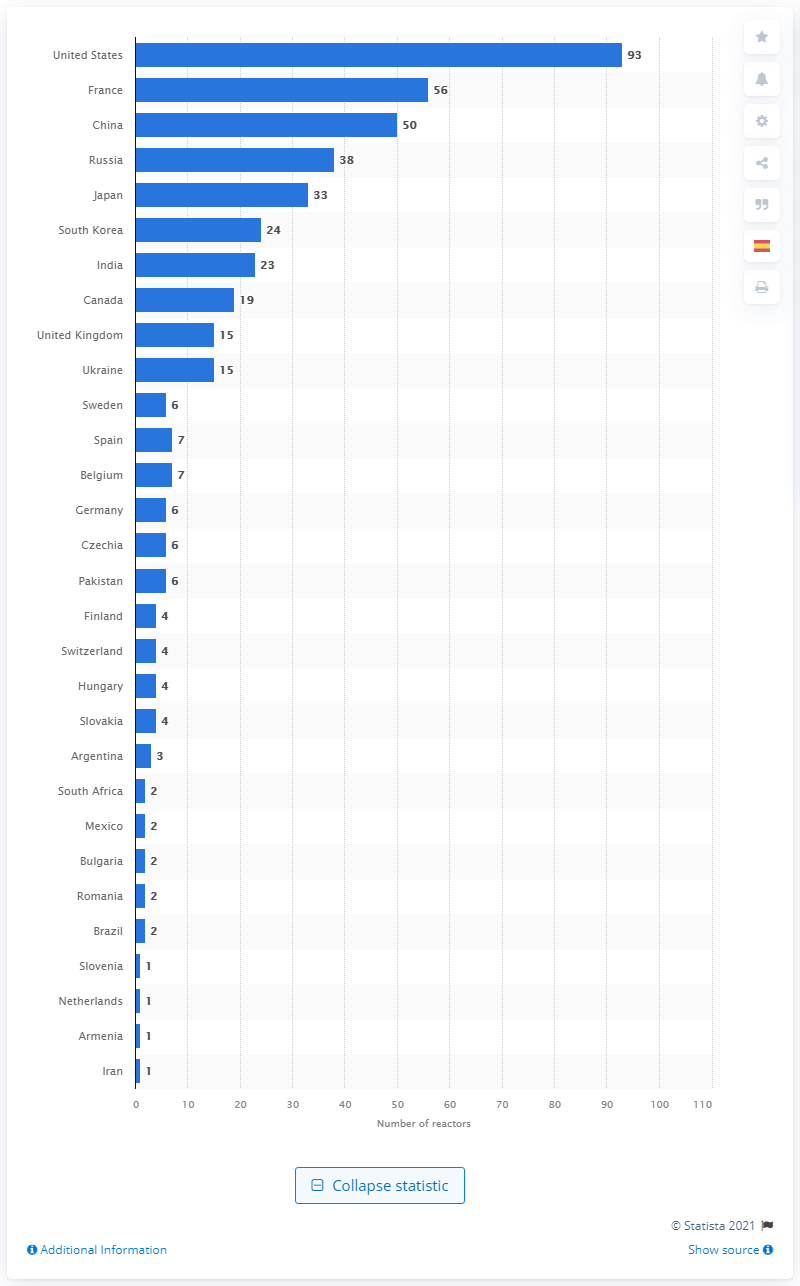Draw attention to some important aspects in this diagram. As of May 2021, there were 15 operational nuclear power reactors in the United Kingdom. 